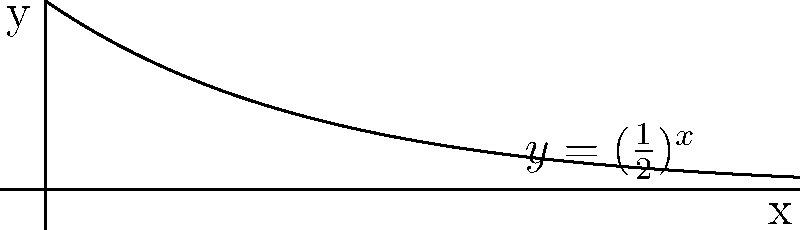In the context of fractal geometry used in digital art generation, consider the function $f(x) = (\frac{1}{2})^x$ shown in the graph. If we were to use this function iteratively to create a fractal pattern, what would be the fractal dimension of the resulting set? To determine the fractal dimension of the set generated by this function, we need to follow these steps:

1. Recall that for a self-similar fractal, the fractal dimension $D$ is given by the equation:

   $$N = r^D$$

   where $N$ is the number of self-similar pieces and $r$ is the scaling factor.

2. In this case, the scaling factor is $\frac{1}{2}$, as we can see from the function $f(x) = (\frac{1}{2})^x$.

3. To find $N$, we need to determine how many copies of the scaled-down version are needed to recreate the original set. In this case, we need 1 copy.

4. Substituting these values into the equation:

   $$1 = (\frac{1}{2})^D$$

5. Taking the logarithm of both sides:

   $$\log(1) = D \log(\frac{1}{2})$$

6. Simplify:

   $$0 = -D \log(2)$$

7. Solve for $D$:

   $$D = \frac{0}{\log(2)} = 0$$

Therefore, the fractal dimension of the set generated by this function is 0.
Answer: 0 